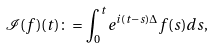Convert formula to latex. <formula><loc_0><loc_0><loc_500><loc_500>\mathcal { I } ( f ) ( t ) \colon = \int _ { 0 } ^ { t } e ^ { i ( t - s ) \Delta } f ( s ) d s ,</formula> 